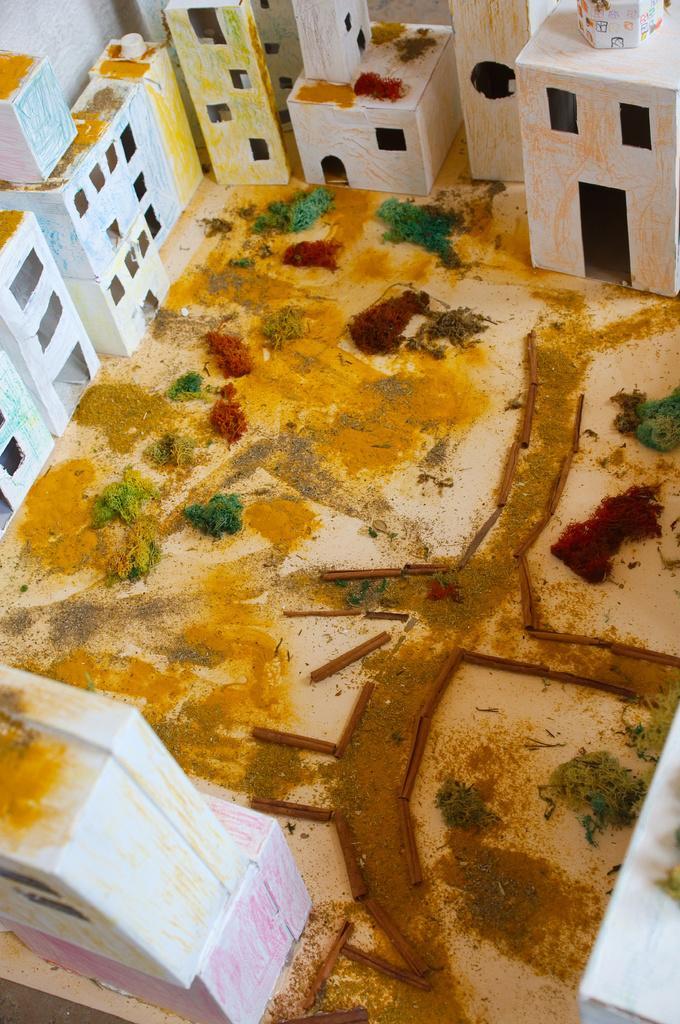In one or two sentences, can you explain what this image depicts? In this we can see a buildings, road, ground, trees are there. 